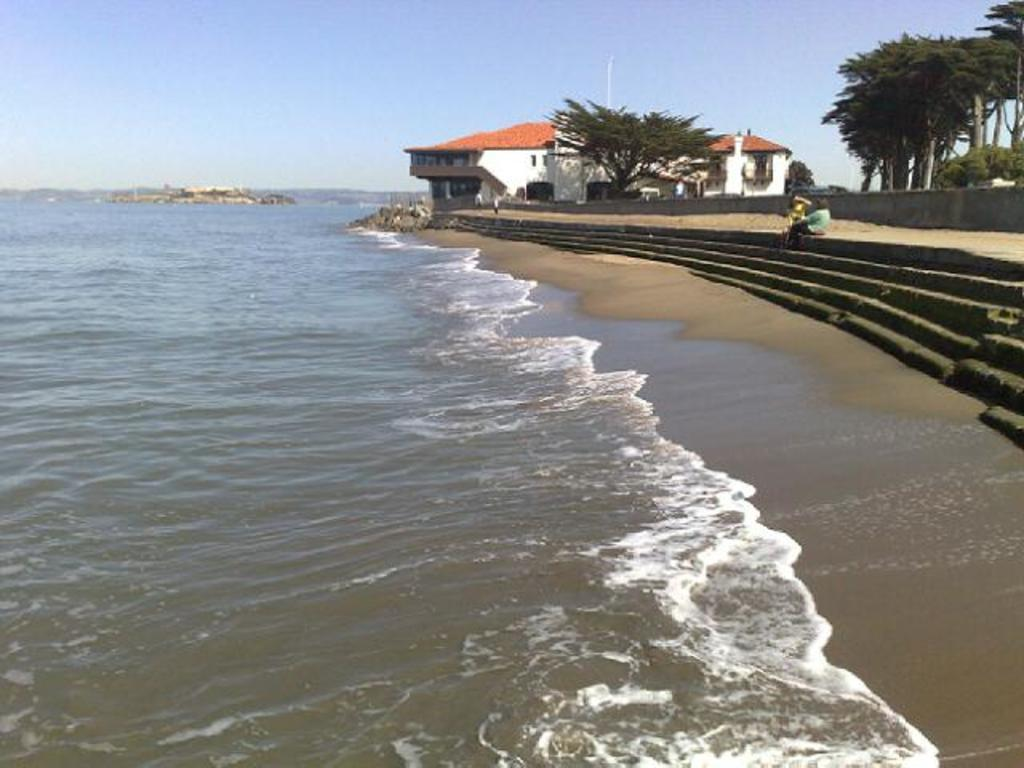What is visible in the image? Water, steps, people, a wall, a building, trees, rocks, and the sky are visible in the image. Can you describe the setting of the image? The image shows a scene with a body of water, steps leading up to a wall, a building in the background, and trees and rocks surrounding the area. How many people are present in the image? There are people in the image, but the exact number is not specified. What is the weather like in the image? The sky is visible in the background, but there is no information about the weather. What type of reaction can be seen from the fairies in the image? There are no fairies present in the image; it features a scene with water, steps, people, a wall, a building, trees, rocks, and the sky. 